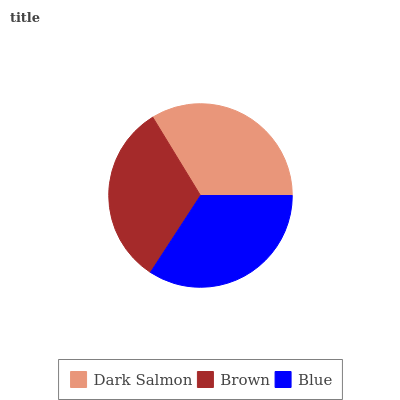Is Brown the minimum?
Answer yes or no. Yes. Is Blue the maximum?
Answer yes or no. Yes. Is Blue the minimum?
Answer yes or no. No. Is Brown the maximum?
Answer yes or no. No. Is Blue greater than Brown?
Answer yes or no. Yes. Is Brown less than Blue?
Answer yes or no. Yes. Is Brown greater than Blue?
Answer yes or no. No. Is Blue less than Brown?
Answer yes or no. No. Is Dark Salmon the high median?
Answer yes or no. Yes. Is Dark Salmon the low median?
Answer yes or no. Yes. Is Blue the high median?
Answer yes or no. No. Is Blue the low median?
Answer yes or no. No. 